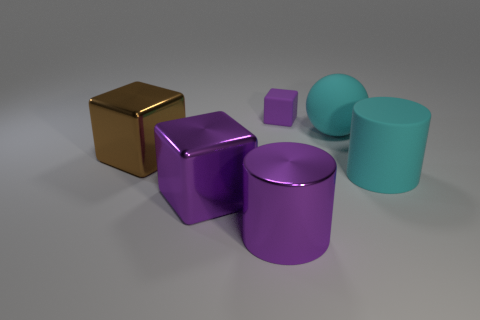Add 1 purple rubber blocks. How many objects exist? 7 Subtract all tiny cubes. How many cubes are left? 2 Subtract all blue balls. How many purple blocks are left? 2 Subtract all cyan cylinders. How many cylinders are left? 1 Subtract all cylinders. How many objects are left? 4 Subtract all yellow cubes. Subtract all cyan balls. How many cubes are left? 3 Subtract all small purple metal balls. Subtract all cylinders. How many objects are left? 4 Add 4 big metallic things. How many big metallic things are left? 7 Add 4 small rubber blocks. How many small rubber blocks exist? 5 Subtract 0 blue blocks. How many objects are left? 6 